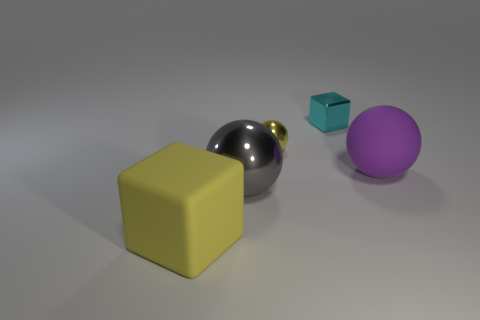Add 1 yellow objects. How many objects exist? 6 Subtract all spheres. How many objects are left? 2 Add 2 gray objects. How many gray objects exist? 3 Subtract 0 green spheres. How many objects are left? 5 Subtract all cyan rubber balls. Subtract all small metallic cubes. How many objects are left? 4 Add 5 big purple things. How many big purple things are left? 6 